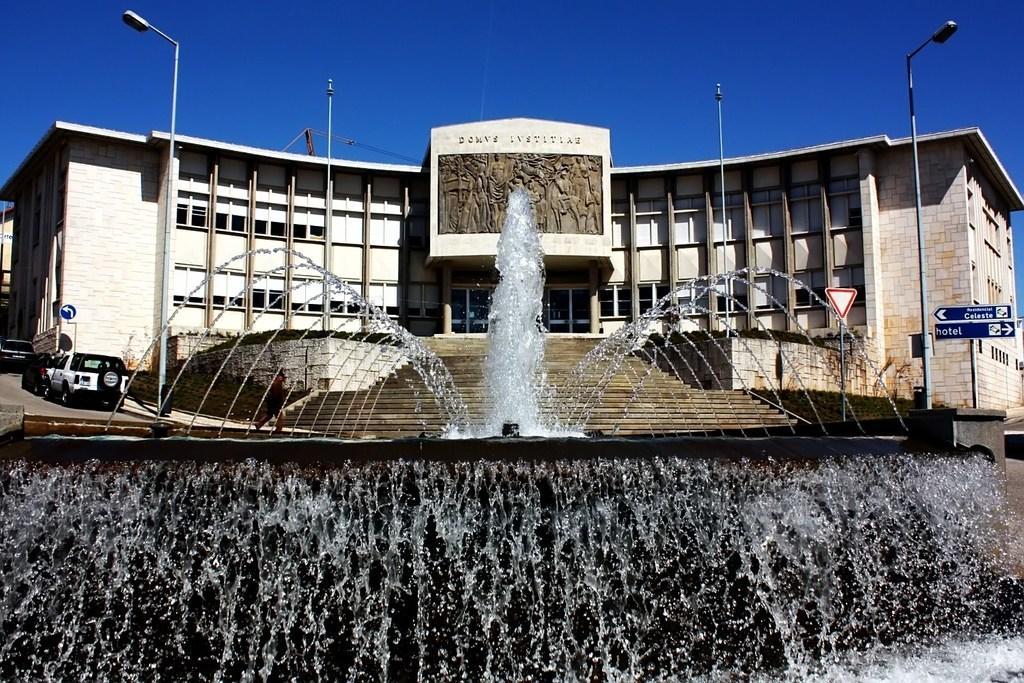Could you give a brief overview of what you see in this image? In the picture we can see a fountain with a waterfall and in the background, we can see a building with a step and some cars park beside the building on the path and we can also see a sky. 